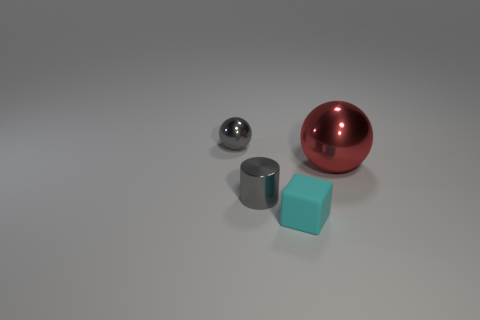Add 1 gray matte cylinders. How many objects exist? 5 Subtract all red balls. How many balls are left? 1 Subtract all cylinders. How many objects are left? 3 Subtract 1 cylinders. How many cylinders are left? 0 Subtract all purple cubes. Subtract all red balls. How many cubes are left? 1 Subtract all yellow cubes. How many red spheres are left? 1 Subtract all rubber blocks. Subtract all small gray metal objects. How many objects are left? 1 Add 4 gray cylinders. How many gray cylinders are left? 5 Add 1 red metallic balls. How many red metallic balls exist? 2 Subtract 0 yellow cylinders. How many objects are left? 4 